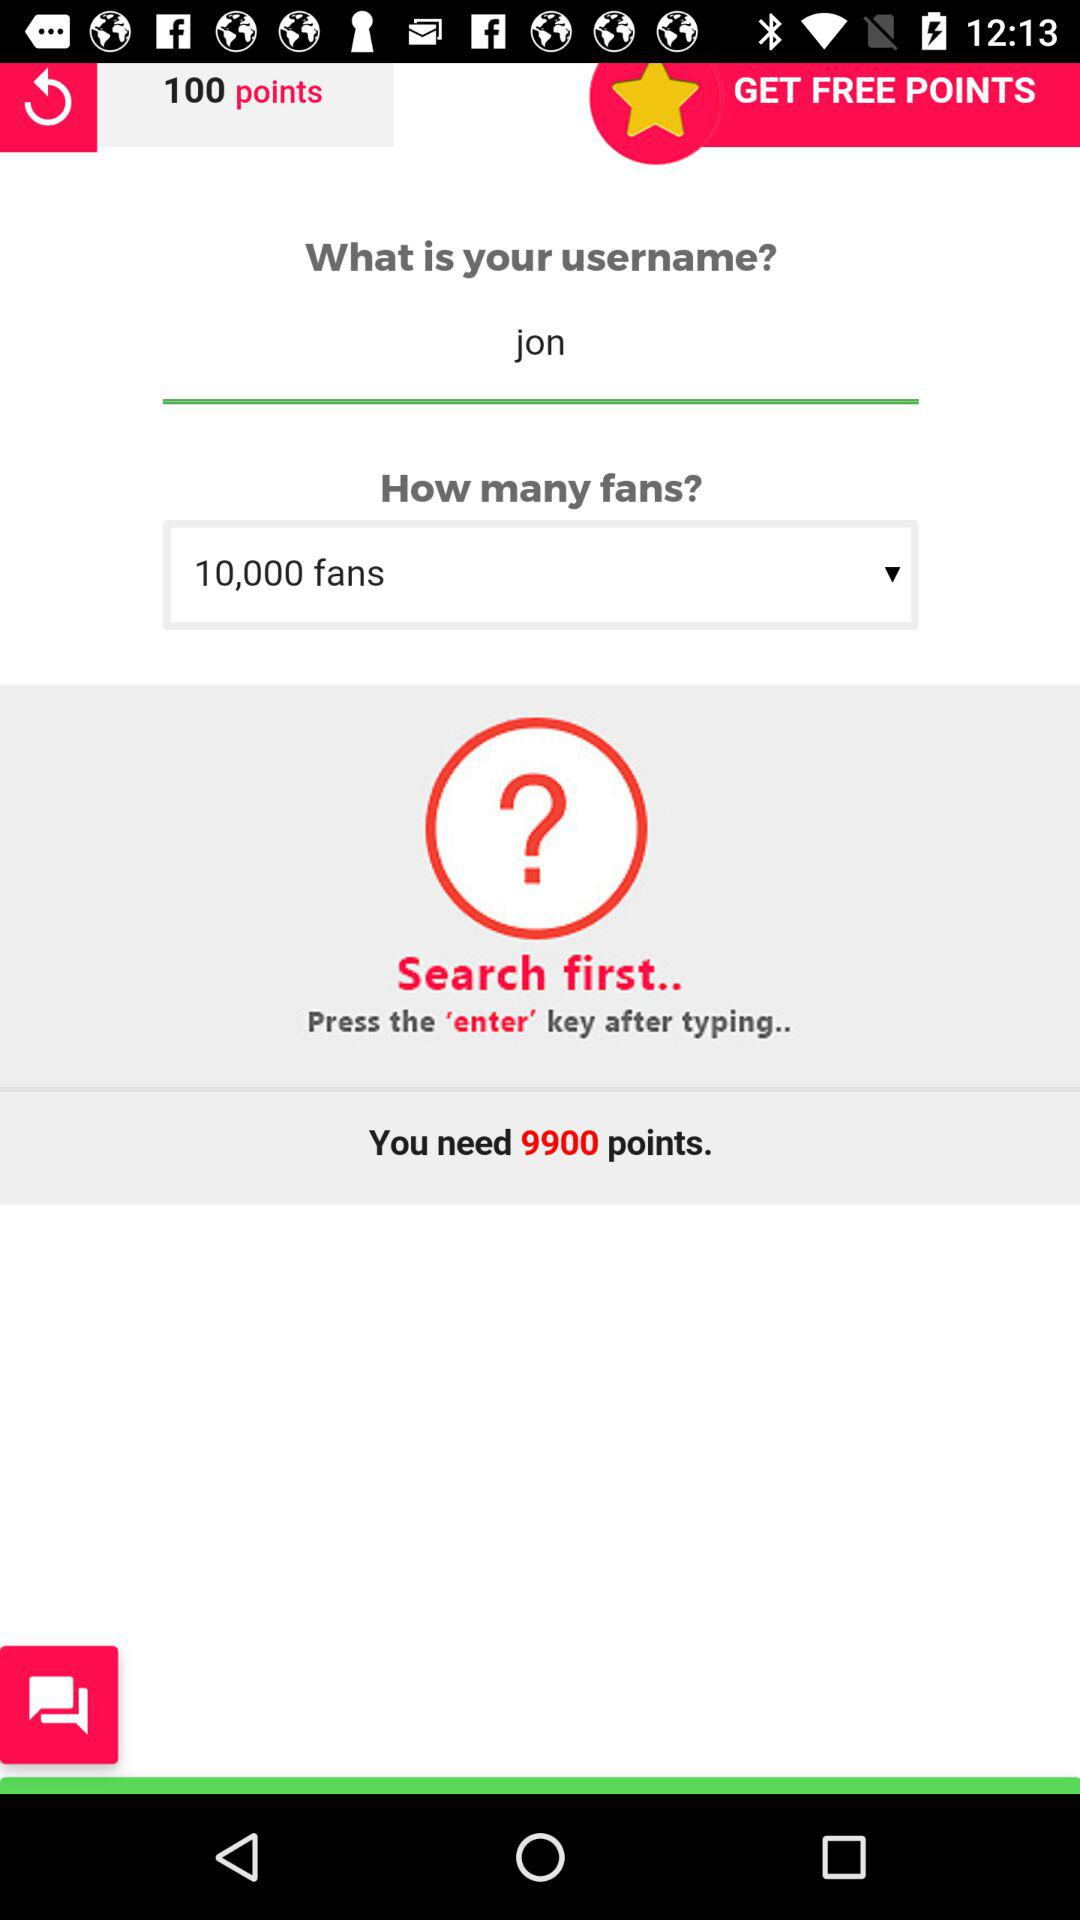What is the username? The username is "jon". 